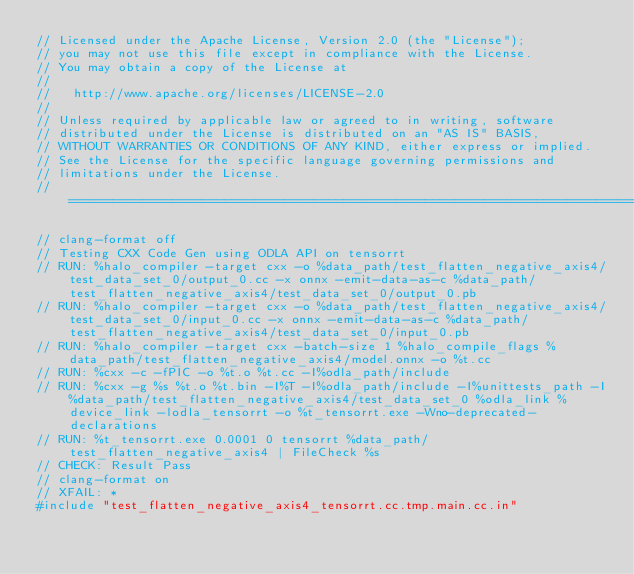<code> <loc_0><loc_0><loc_500><loc_500><_C++_>// Licensed under the Apache License, Version 2.0 (the "License");
// you may not use this file except in compliance with the License.
// You may obtain a copy of the License at
//
//   http://www.apache.org/licenses/LICENSE-2.0
//
// Unless required by applicable law or agreed to in writing, software
// distributed under the License is distributed on an "AS IS" BASIS,
// WITHOUT WARRANTIES OR CONDITIONS OF ANY KIND, either express or implied.
// See the License for the specific language governing permissions and
// limitations under the License.
// =============================================================================

// clang-format off
// Testing CXX Code Gen using ODLA API on tensorrt
// RUN: %halo_compiler -target cxx -o %data_path/test_flatten_negative_axis4/test_data_set_0/output_0.cc -x onnx -emit-data-as-c %data_path/test_flatten_negative_axis4/test_data_set_0/output_0.pb
// RUN: %halo_compiler -target cxx -o %data_path/test_flatten_negative_axis4/test_data_set_0/input_0.cc -x onnx -emit-data-as-c %data_path/test_flatten_negative_axis4/test_data_set_0/input_0.pb
// RUN: %halo_compiler -target cxx -batch-size 1 %halo_compile_flags %data_path/test_flatten_negative_axis4/model.onnx -o %t.cc
// RUN: %cxx -c -fPIC -o %t.o %t.cc -I%odla_path/include
// RUN: %cxx -g %s %t.o %t.bin -I%T -I%odla_path/include -I%unittests_path -I%data_path/test_flatten_negative_axis4/test_data_set_0 %odla_link %device_link -lodla_tensorrt -o %t_tensorrt.exe -Wno-deprecated-declarations
// RUN: %t_tensorrt.exe 0.0001 0 tensorrt %data_path/test_flatten_negative_axis4 | FileCheck %s
// CHECK: Result Pass
// clang-format on
// XFAIL: *
#include "test_flatten_negative_axis4_tensorrt.cc.tmp.main.cc.in"
</code> 